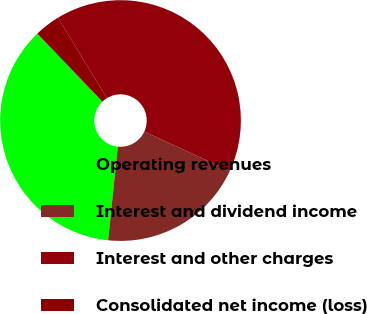Convert chart. <chart><loc_0><loc_0><loc_500><loc_500><pie_chart><fcel>Operating revenues<fcel>Interest and dividend income<fcel>Interest and other charges<fcel>Consolidated net income (loss)<nl><fcel>36.21%<fcel>19.76%<fcel>40.57%<fcel>3.46%<nl></chart> 